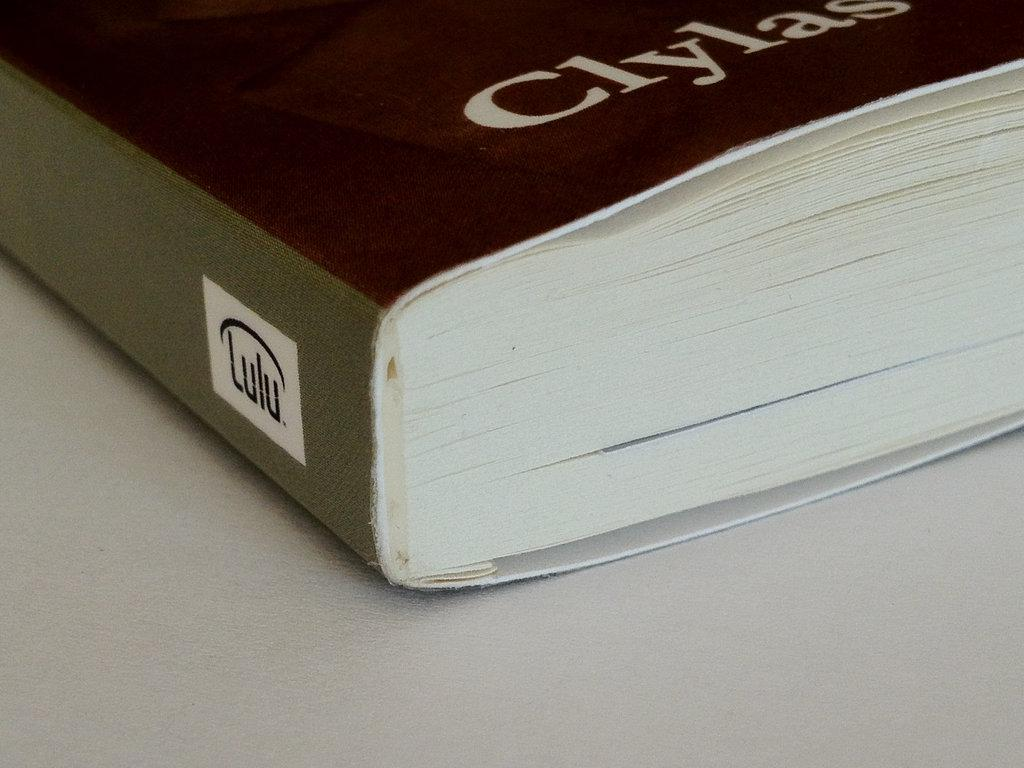<image>
Render a clear and concise summary of the photo. a book that says 'clylas' at the bottom of it 